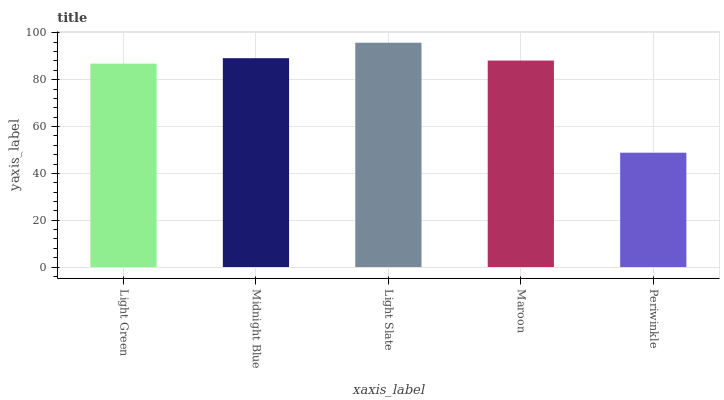Is Periwinkle the minimum?
Answer yes or no. Yes. Is Light Slate the maximum?
Answer yes or no. Yes. Is Midnight Blue the minimum?
Answer yes or no. No. Is Midnight Blue the maximum?
Answer yes or no. No. Is Midnight Blue greater than Light Green?
Answer yes or no. Yes. Is Light Green less than Midnight Blue?
Answer yes or no. Yes. Is Light Green greater than Midnight Blue?
Answer yes or no. No. Is Midnight Blue less than Light Green?
Answer yes or no. No. Is Maroon the high median?
Answer yes or no. Yes. Is Maroon the low median?
Answer yes or no. Yes. Is Midnight Blue the high median?
Answer yes or no. No. Is Periwinkle the low median?
Answer yes or no. No. 